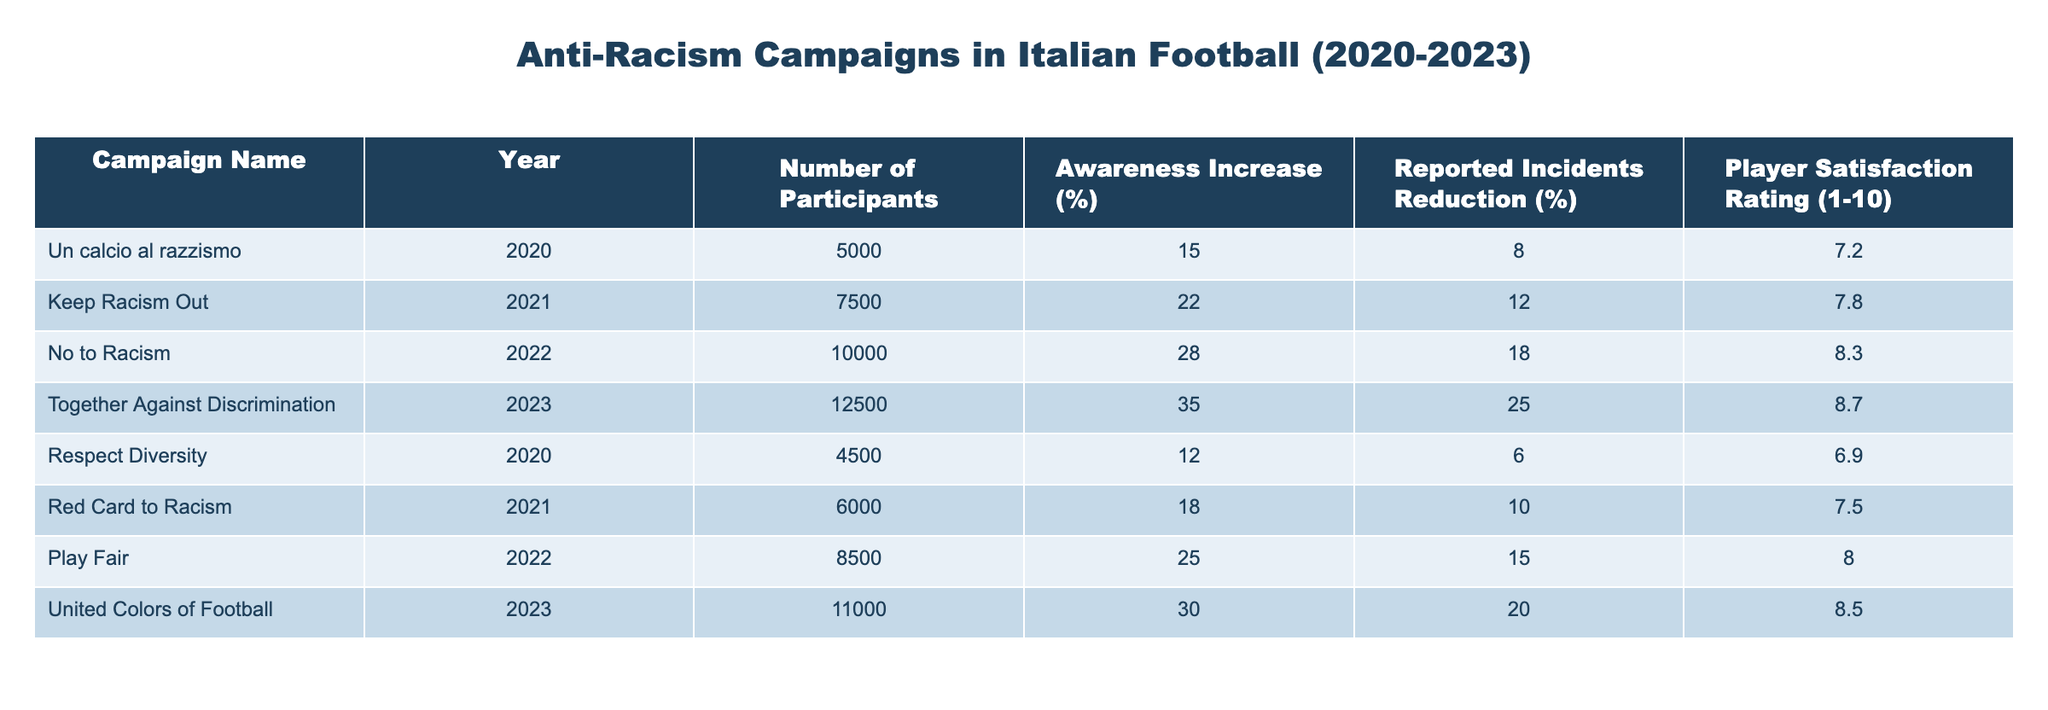What was the awareness increase percentage for the "No to Racism" campaign in 2022? The table shows that the "No to Racism" campaign in 2022 had an awareness increase of 28%.
Answer: 28% How many participants were involved in the "Together Against Discrimination" campaign in 2023? According to the table, the "Together Against Discrimination" campaign in 2023 had 12,500 participants.
Answer: 12,500 What is the average player satisfaction rating across all campaigns listed in the table? To calculate the average, sum the player satisfaction ratings (7.2 + 7.8 + 8.3 + 8.7 + 6.9 + 7.5 + 8.0 + 8.5 = 63.9) and divide by the number of campaigns (8). So, the average is 63.9/8 = 7.9875, which rounds to 8.0.
Answer: 8.0 Did the "Keep Racism Out" campaign have a higher reduction in reported incidents compared to "Red Card to Racism"? The table shows that "Keep Racism Out" had a reported incidents reduction of 12%, while "Red Card to Racism" had 10%. Since 12% > 10%, the statement is true.
Answer: Yes Which campaign had the highest increase in awareness and how much was it? The "Together Against Discrimination" campaign in 2023 had the highest awareness increase at 35%, compared to other campaigns listed.
Answer: "Together Against Discrimination", 35% 